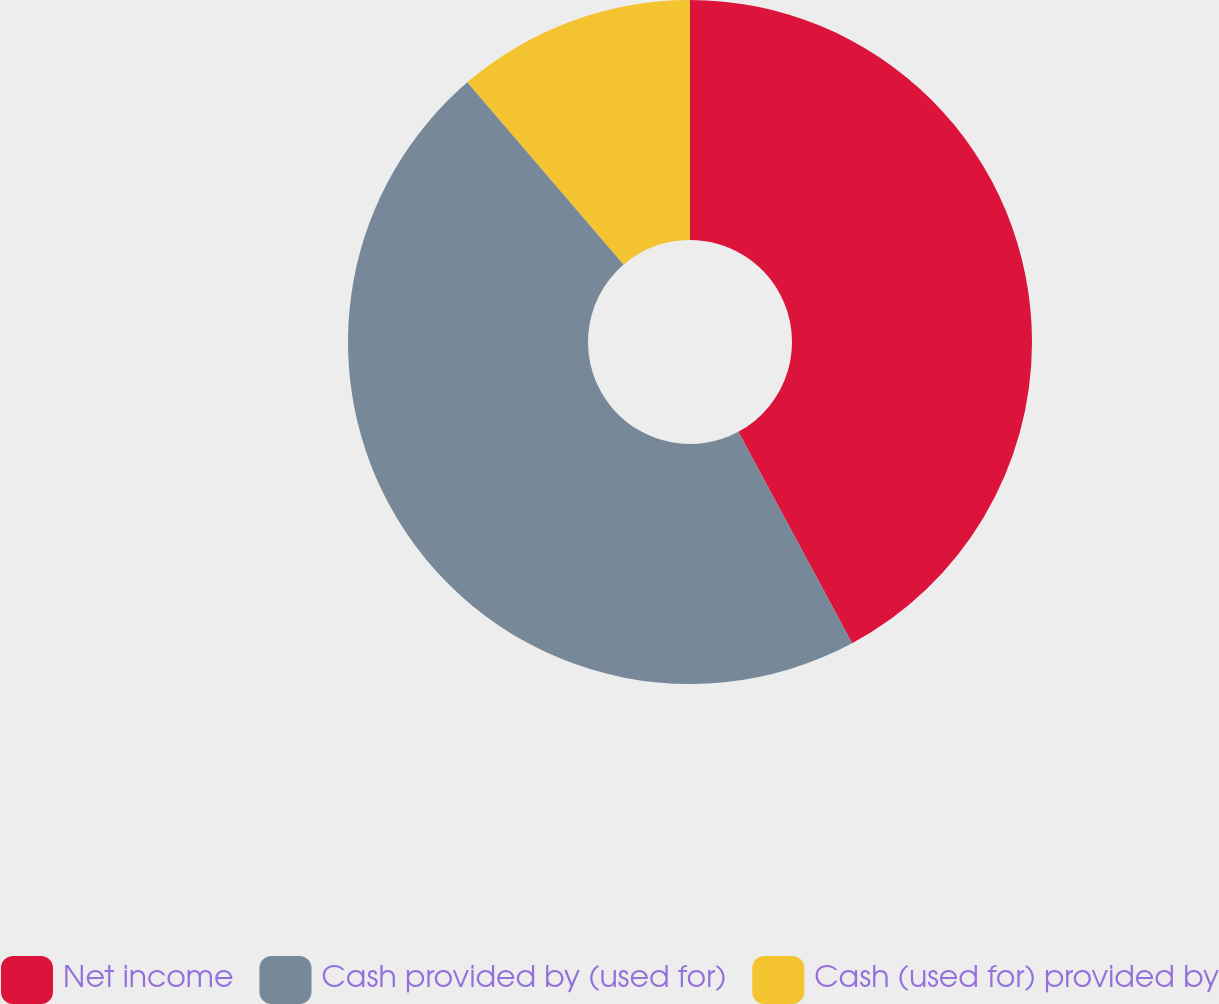Convert chart. <chart><loc_0><loc_0><loc_500><loc_500><pie_chart><fcel>Net income<fcel>Cash provided by (used for)<fcel>Cash (used for) provided by<nl><fcel>42.14%<fcel>46.58%<fcel>11.28%<nl></chart> 